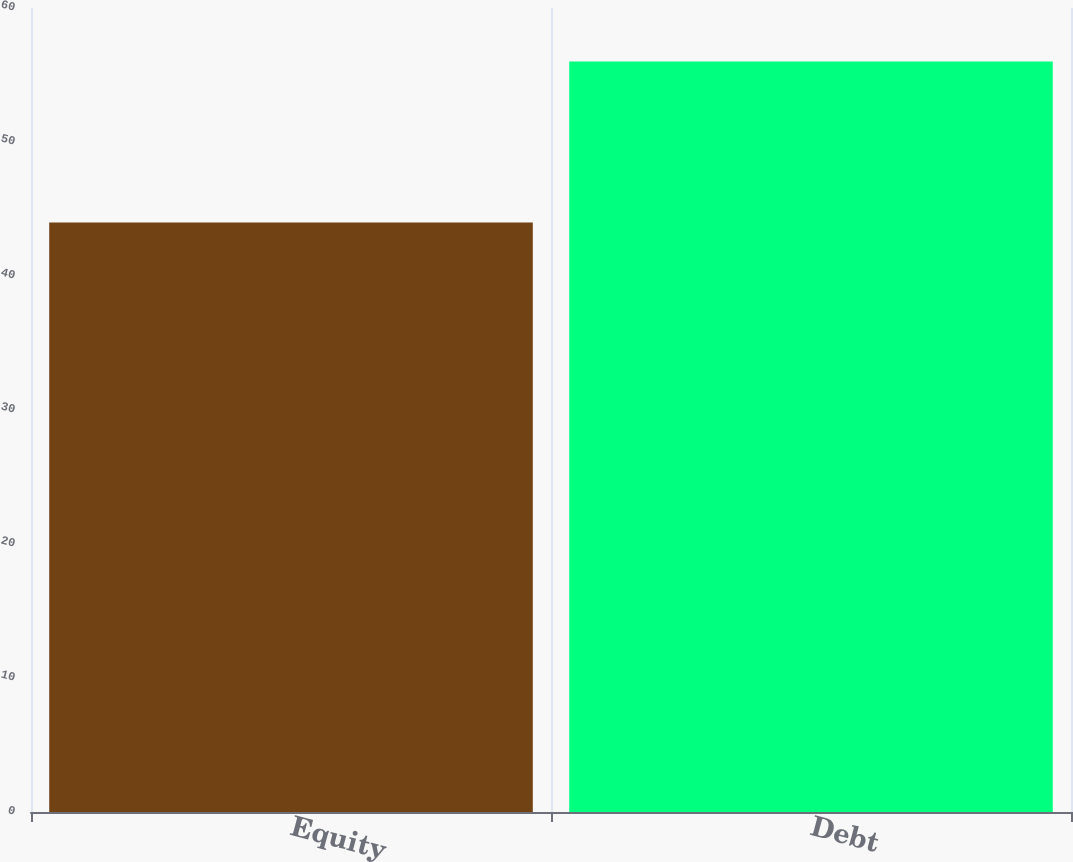<chart> <loc_0><loc_0><loc_500><loc_500><bar_chart><fcel>Equity<fcel>Debt<nl><fcel>44<fcel>56<nl></chart> 